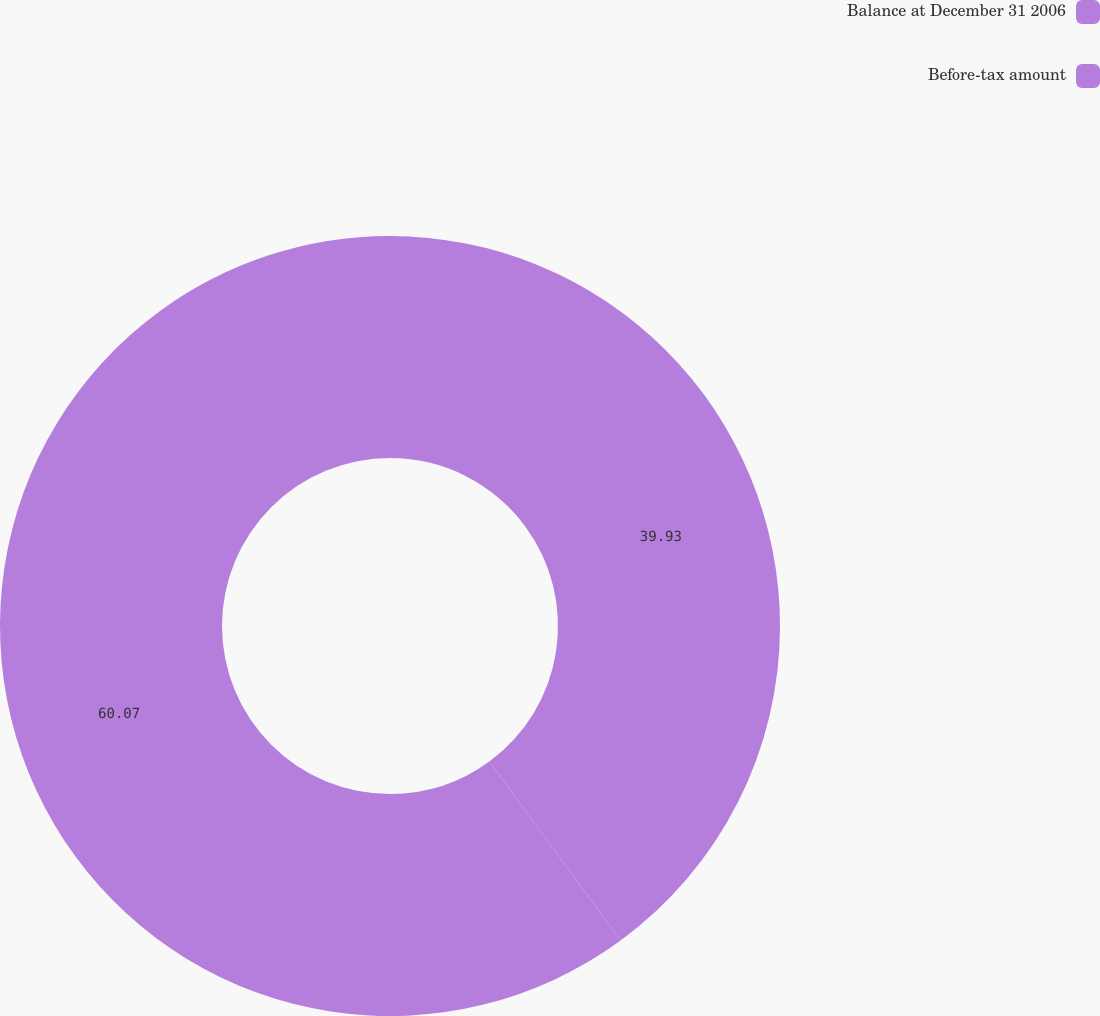Convert chart. <chart><loc_0><loc_0><loc_500><loc_500><pie_chart><fcel>Balance at December 31 2006<fcel>Before-tax amount<nl><fcel>39.93%<fcel>60.07%<nl></chart> 